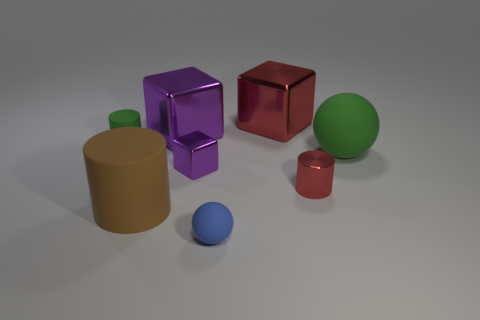What is the color of the large cylinder?
Your answer should be very brief. Brown. There is a purple metal thing in front of the cylinder that is behind the red shiny cylinder; what is its shape?
Offer a very short reply. Cube. Are there any blue things made of the same material as the large cylinder?
Offer a terse response. Yes. Is the size of the purple metallic object behind the green matte cylinder the same as the brown cylinder?
Provide a short and direct response. Yes. How many brown objects are either metallic cylinders or large rubber balls?
Give a very brief answer. 0. There is a tiny object that is on the right side of the blue object; what is its material?
Keep it short and to the point. Metal. There is a shiny object on the right side of the red cube; how many shiny things are left of it?
Keep it short and to the point. 3. How many large green things are the same shape as the tiny blue matte thing?
Keep it short and to the point. 1. What number of red metal things are there?
Your answer should be compact. 2. What is the color of the cylinder to the right of the large brown cylinder?
Your answer should be compact. Red. 